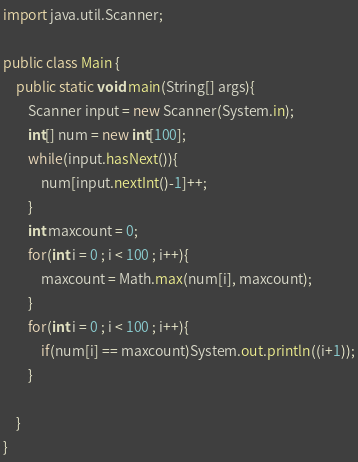<code> <loc_0><loc_0><loc_500><loc_500><_Java_>import java.util.Scanner;

public class Main {
    public static void main(String[] args){
    	Scanner input = new Scanner(System.in);
    	int[] num = new int[100];
    	while(input.hasNext()){
    		num[input.nextInt()-1]++;
    	}
    	int maxcount = 0;
    	for(int i = 0 ; i < 100 ; i++){
    		maxcount = Math.max(num[i], maxcount);
    	}
    	for(int i = 0 ; i < 100 ; i++){
    		if(num[i] == maxcount)System.out.println((i+1));
    	}
		
    }
}</code> 